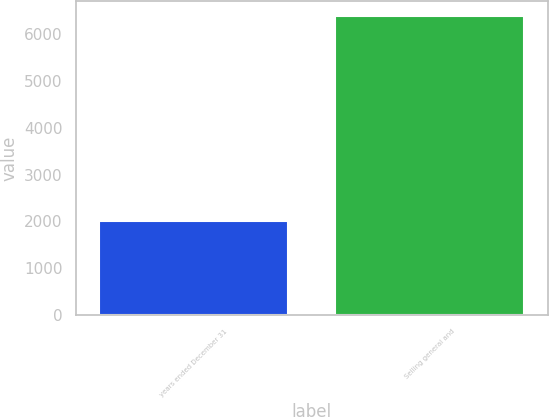<chart> <loc_0><loc_0><loc_500><loc_500><bar_chart><fcel>years ended December 31<fcel>Selling general and<nl><fcel>2015<fcel>6387<nl></chart> 